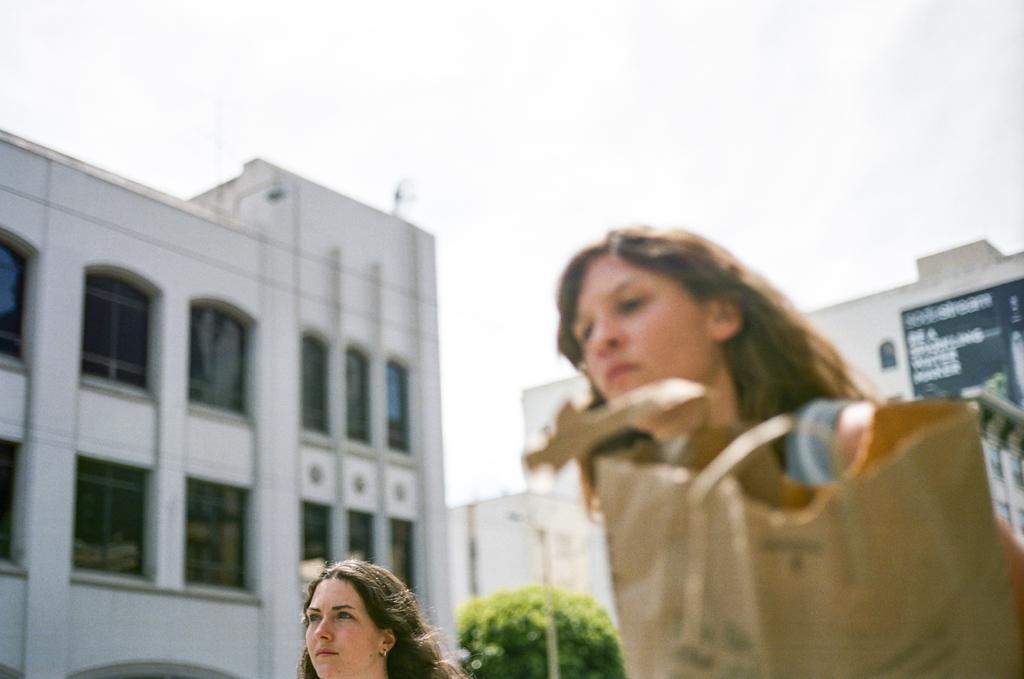Can you describe this image briefly? In this image we can see two women and a bag. On the backside we can see some buildings with windows, a tree, a street pole and the sky which looks cloudy. 